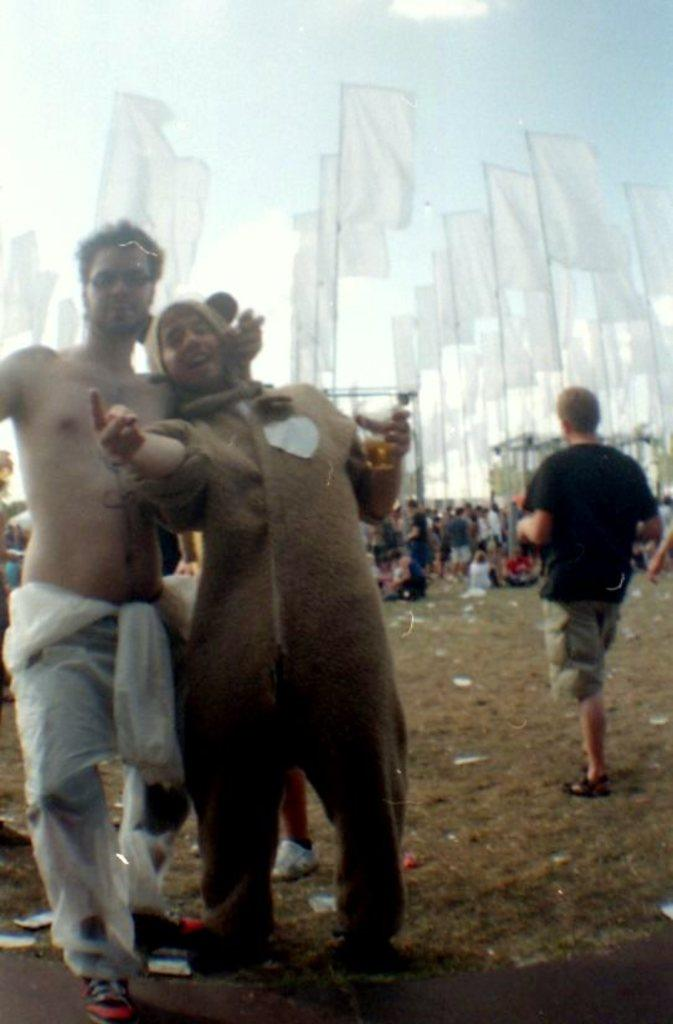How many people are on the ground in the image? There are three persons on the ground in the image. What can be seen in the background of the image? There is a group of people and flags in the background, as well as the sky. What type of beef is being served to the group of people in the image? There is no beef present in the image; it only shows three persons on the ground and a group of people, flags, and the sky in the background. 